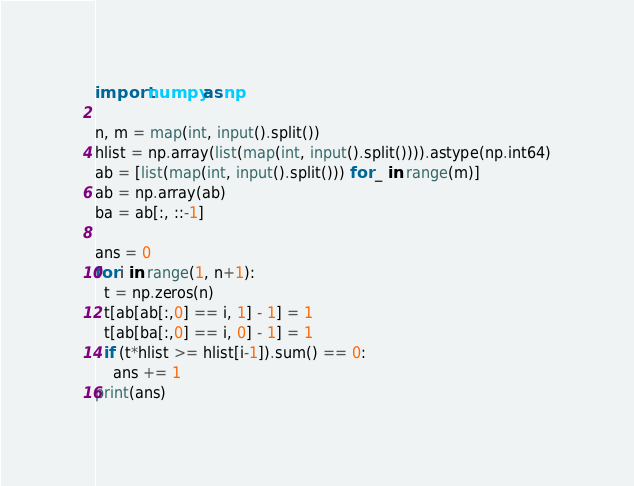Convert code to text. <code><loc_0><loc_0><loc_500><loc_500><_Python_>import numpy as np

n, m = map(int, input().split())
hlist = np.array(list(map(int, input().split()))).astype(np.int64)
ab = [list(map(int, input().split())) for _ in range(m)]
ab = np.array(ab)
ba = ab[:, ::-1]

ans = 0
for i in range(1, n+1):
  t = np.zeros(n)
  t[ab[ab[:,0] == i, 1] - 1] = 1
  t[ab[ba[:,0] == i, 0] - 1] = 1
  if (t*hlist >= hlist[i-1]).sum() == 0:
    ans += 1
print(ans)</code> 